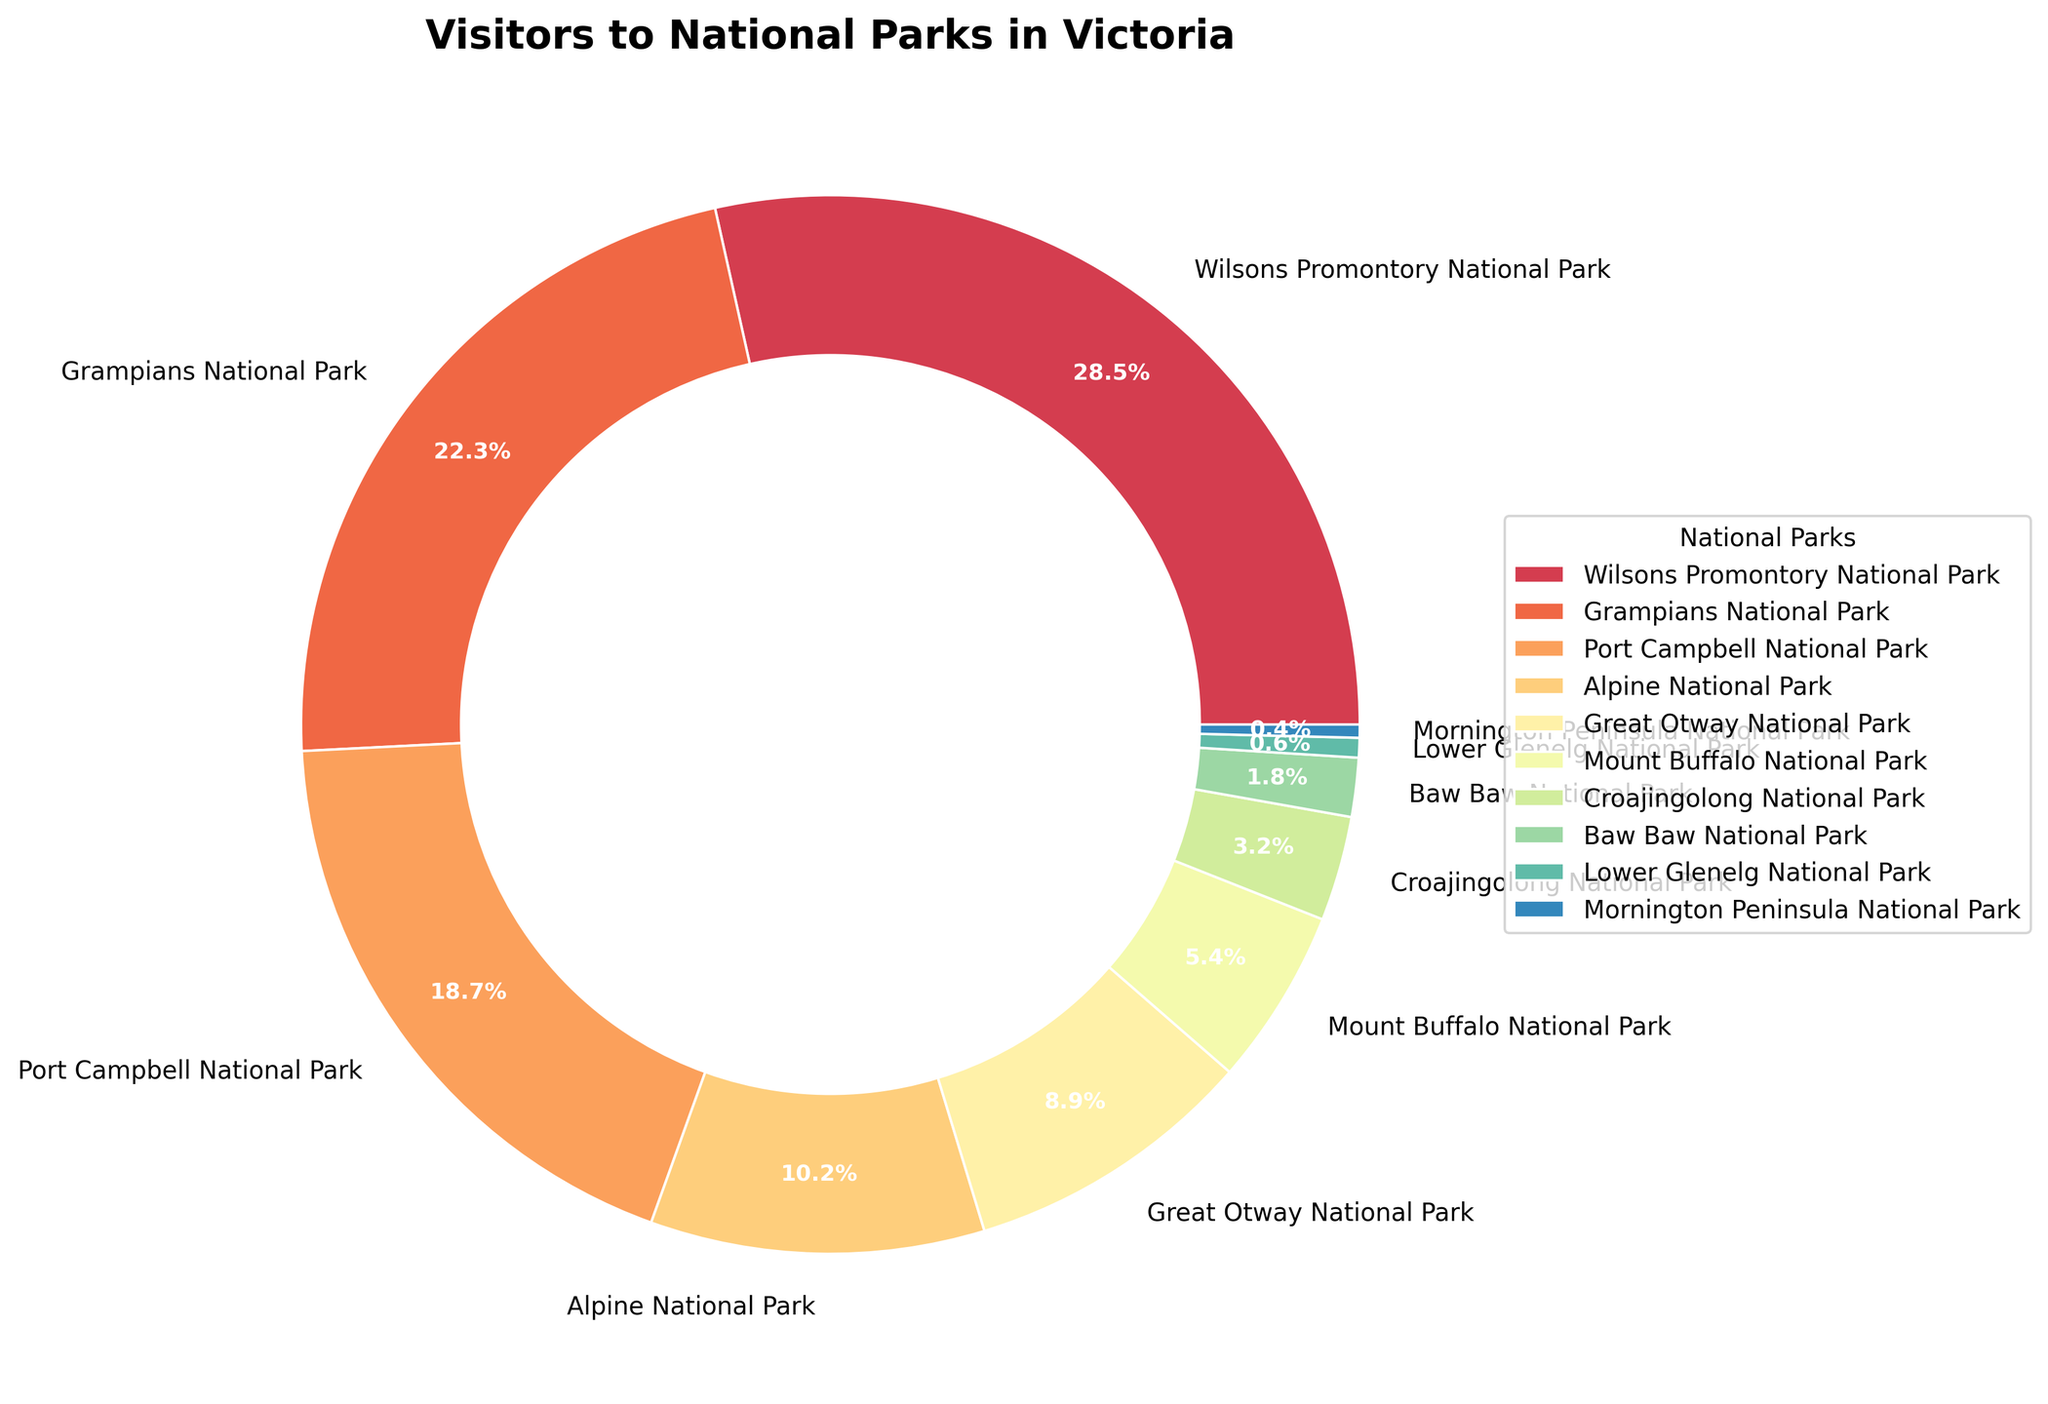Which national park receives the highest percentage of visitors? From the figure, Wilsons Promontory National Park has the largest section of the pie chart, indicating it receives the highest percentage of visitors.
Answer: Wilsons Promontory National Park How much higher is the percentage of visitors to Grampians National Park compared to Great Otway National Park? Grampians National Park has 22.3% of the visitors, while Great Otway National Park has 8.9%. The difference is 22.3% - 8.9% = 13.4%.
Answer: 13.4% What is the combined percentage of visitors to the three least visited parks? The least visited parks are Mornington Peninsula National Park (0.4%), Lower Glenelg National Park (0.6%), and Baw Baw National Park (1.8%). The combined percentage is 0.4% + 0.6% + 1.8% = 2.8%.
Answer: 2.8% Are there more visitors to Alpine National Park or Port Campbell National Park? From the figure, Port Campbell National Park receives a higher percentage of visitors (18.7%) compared to Alpine National Park (10.2%).
Answer: Port Campbell National Park What percentage of visitors does Mount Buffalo National Park receive relative to the total? Referring to the pie chart, Mount Buffalo National Park's section indicates it receives 5.4% of the visitors.
Answer: 5.4% What is the percentage difference between the most visited and least visited national parks? The most visited national park is Wilsons Promontory with 28.5%, and the least visited is Mornington Peninsula with 0.4%. The difference is 28.5% - 0.4% = 28.1%.
Answer: 28.1% Which national parks receive less than 10% of the visitors? From the pie chart, Alpine National Park (10.2%) is the cutoff. Therefore, the parks receiving less than 10% are Great Otway National Park (8.9%), Mount Buffalo National Park (5.4%), Croajingolong National Park (3.2%), Baw Baw National Park (1.8%), Lower Glenelg National Park (0.6%), and Mornington Peninsula National Park (0.4%).
Answer: Six parks How many parks receive between 15% and 25% of the visitors? By examining the pie chart, only Grampians National Park (22.3%) and Port Campbell National Park (18.7%) fall within this range.
Answer: Two parks 